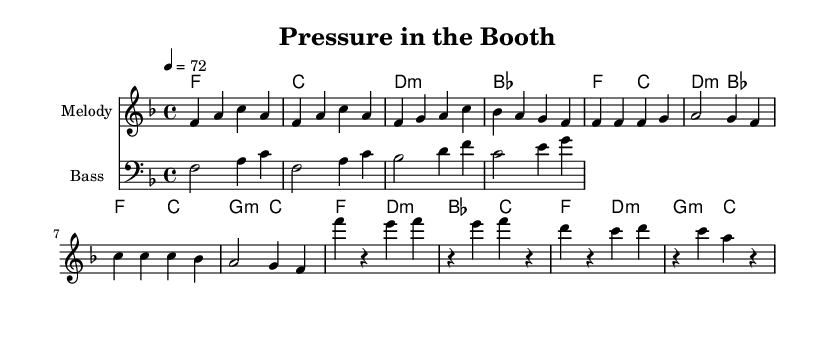What is the key signature of this music? The key signature in the top left corner indicates F major, which has one flat (B flat).
Answer: F major What is the time signature of this music? The time signature, shown at the beginning of the music, is 4/4, meaning there are four beats in each measure.
Answer: 4/4 What is the tempo marking of this piece? The tempo marking indicates that the piece should be played at a speed of 72 beats per minute.
Answer: 72 How many measures does the intro section consist of? By counting the groupings of notes, the intro section has four measures.
Answer: 4 What is the chord that accompanies the last bar of the verse? The last bar of the verse shows a G minor chord, completed in the harmony line.
Answer: G minor Which chords are used in the chorus section? The chords in the chorus sequence, as seen in the harmony line, are F, D minor, B flat, and C.
Answer: F, D minor, B flat, C What rhythmic pattern is used in the chorus melody? The rhythm in the chorus melody consists of quarter notes followed by rests, creating a syncopated feel.
Answer: Quarter notes and rests 